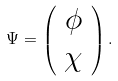<formula> <loc_0><loc_0><loc_500><loc_500>\Psi = \left ( \begin{array} { c } \phi \\ \chi \end{array} \right ) .</formula> 